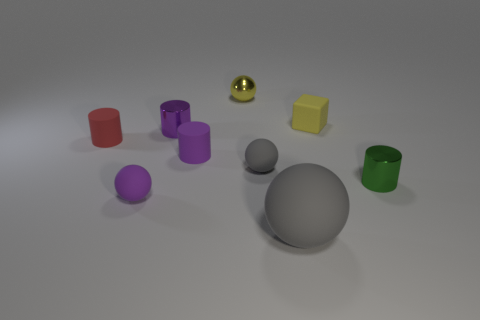How many things are small spheres that are behind the small red cylinder or tiny metallic balls?
Keep it short and to the point. 1. What material is the other gray ball that is the same size as the shiny ball?
Keep it short and to the point. Rubber. What is the color of the rubber object behind the small purple cylinder behind the tiny red cylinder?
Offer a very short reply. Yellow. There is a tiny red rubber thing; what number of small rubber objects are to the right of it?
Provide a succinct answer. 4. The cube is what color?
Provide a succinct answer. Yellow. What number of small objects are brown matte cubes or green things?
Your answer should be compact. 1. There is a tiny metallic thing that is behind the rubber cube; does it have the same color as the rubber cylinder that is in front of the tiny red rubber object?
Make the answer very short. No. What number of other objects are there of the same color as the tiny cube?
Provide a short and direct response. 1. There is a gray thing behind the green metal thing; what is its shape?
Make the answer very short. Sphere. Are there fewer things than purple cylinders?
Your answer should be compact. No. 